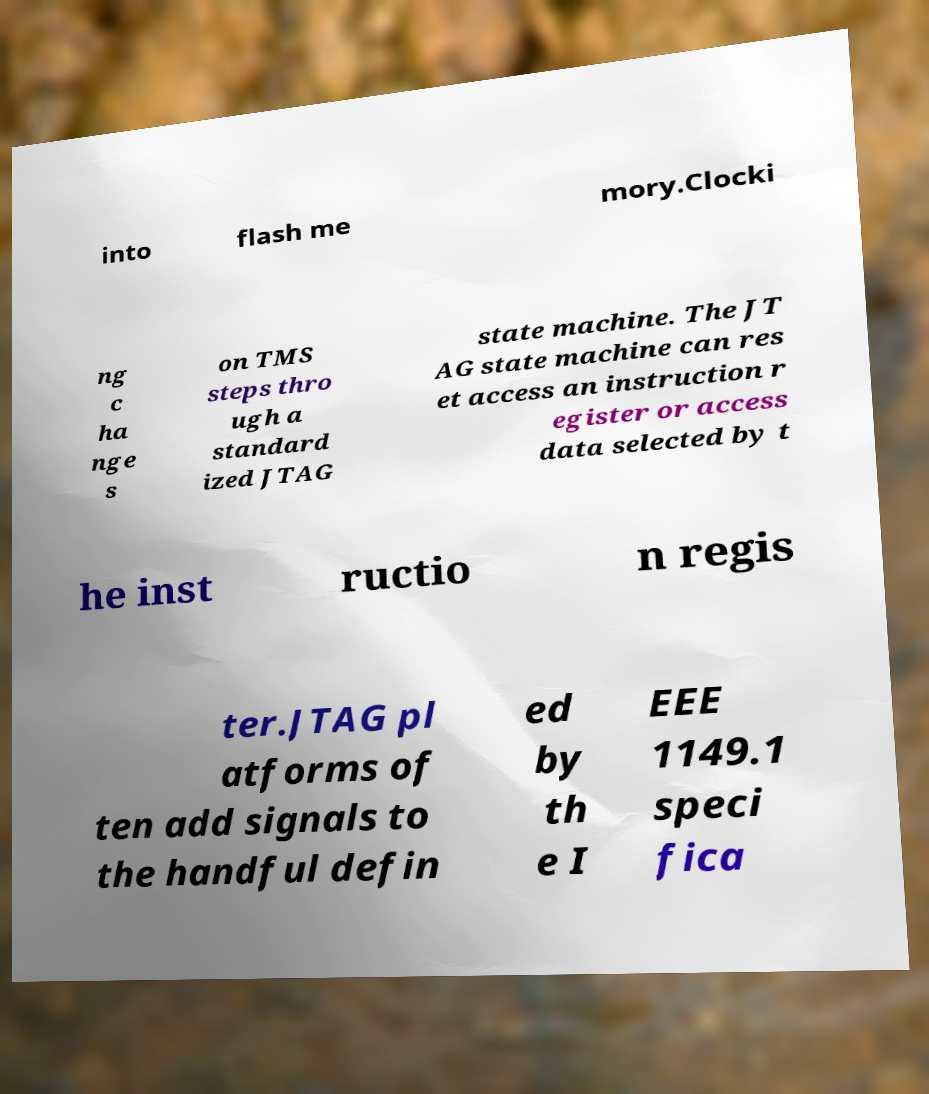For documentation purposes, I need the text within this image transcribed. Could you provide that? into flash me mory.Clocki ng c ha nge s on TMS steps thro ugh a standard ized JTAG state machine. The JT AG state machine can res et access an instruction r egister or access data selected by t he inst ructio n regis ter.JTAG pl atforms of ten add signals to the handful defin ed by th e I EEE 1149.1 speci fica 